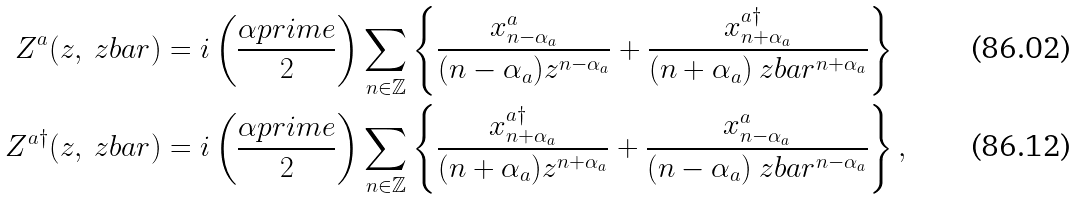<formula> <loc_0><loc_0><loc_500><loc_500>Z ^ { a } ( z , \ z b a r ) & = i \left ( \frac { \alpha p r i m e } { 2 } \right ) \sum _ { n \in \mathbb { Z } } \left \{ \frac { x ^ { a } _ { n - \alpha _ { a } } } { ( n - \alpha _ { a } ) z ^ { n - \alpha _ { a } } } + \frac { x ^ { a \dagger } _ { n + \alpha _ { a } } } { ( n + \alpha _ { a } ) \ z b a r ^ { n + \alpha _ { a } } } \right \} \\ Z ^ { a \dagger } ( z , \ z b a r ) & = i \left ( \frac { \alpha p r i m e } { 2 } \right ) \sum _ { n \in \mathbb { Z } } \left \{ \frac { x ^ { a \dagger } _ { n + \alpha _ { a } } } { ( n + \alpha _ { a } ) z ^ { n + \alpha _ { a } } } + \frac { x ^ { a } _ { n - \alpha _ { a } } } { ( n - \alpha _ { a } ) \ z b a r ^ { n - \alpha _ { a } } } \right \} ,</formula> 